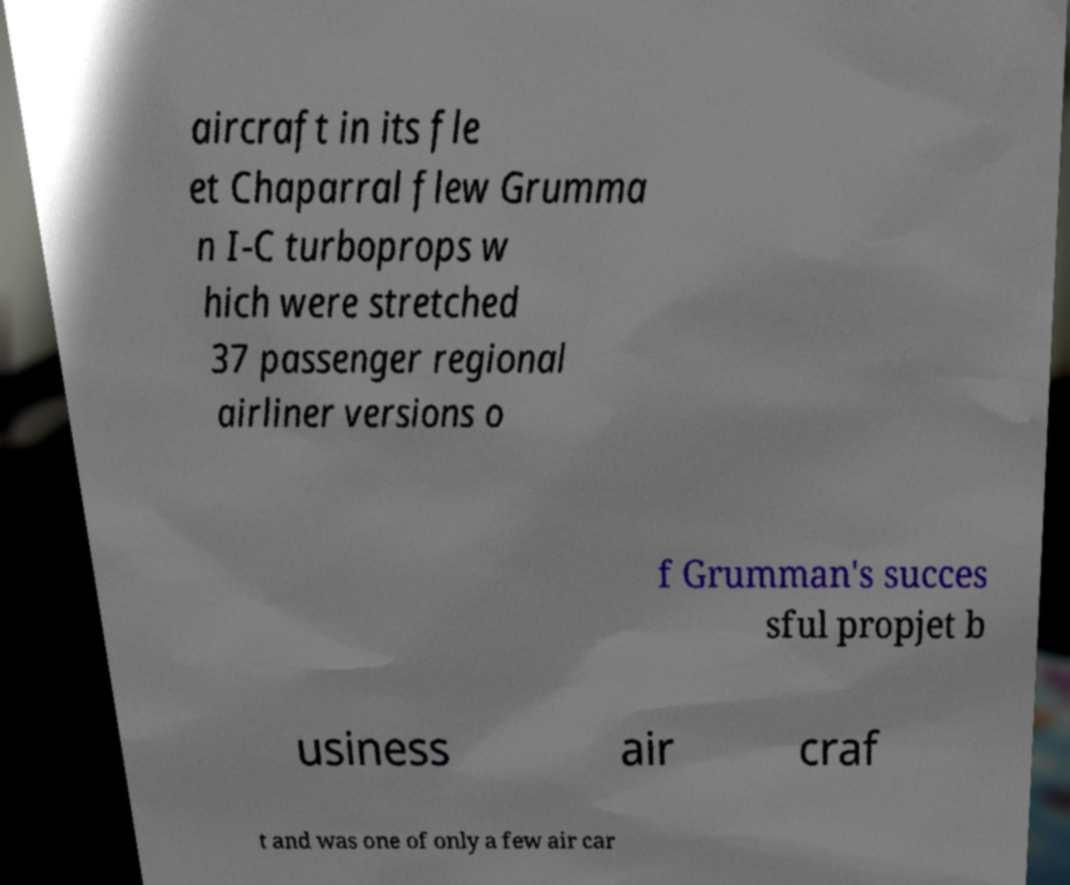Please identify and transcribe the text found in this image. aircraft in its fle et Chaparral flew Grumma n I-C turboprops w hich were stretched 37 passenger regional airliner versions o f Grumman's succes sful propjet b usiness air craf t and was one of only a few air car 